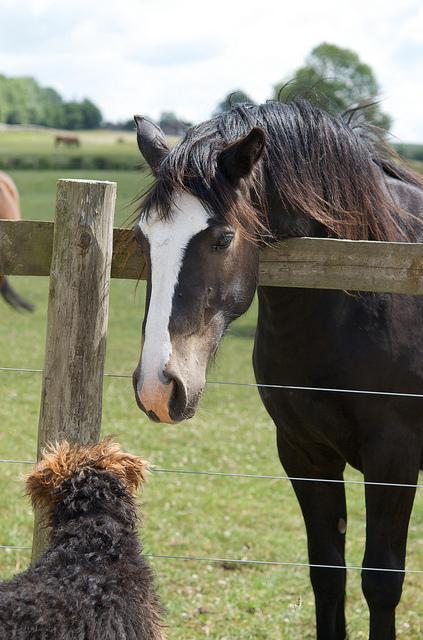How many beds do the cats have?
Give a very brief answer. 0. 